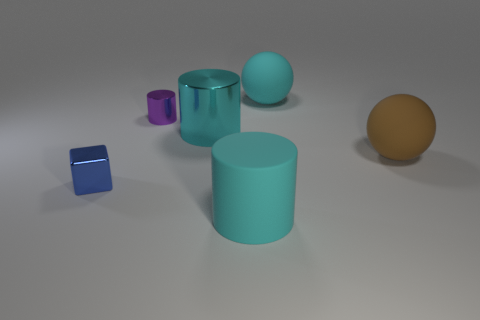How many shiny things are the same color as the rubber cylinder?
Give a very brief answer. 1. Is the number of big brown spheres that are in front of the blue cube less than the number of large cylinders that are left of the purple cylinder?
Give a very brief answer. No. What is the size of the metallic object in front of the large metal thing?
Ensure brevity in your answer.  Small. There is a matte sphere that is the same color as the large metal cylinder; what is its size?
Your response must be concise. Large. Are there any tiny yellow objects that have the same material as the cyan ball?
Provide a succinct answer. No. Are the blue thing and the small purple thing made of the same material?
Offer a very short reply. Yes. There is a matte cylinder that is the same size as the brown rubber sphere; what is its color?
Provide a short and direct response. Cyan. What number of other things are the same shape as the cyan shiny object?
Give a very brief answer. 2. There is a cyan shiny thing; is it the same size as the matte object that is to the right of the big cyan ball?
Ensure brevity in your answer.  Yes. How many things are big red cylinders or large brown spheres?
Your answer should be compact. 1. 